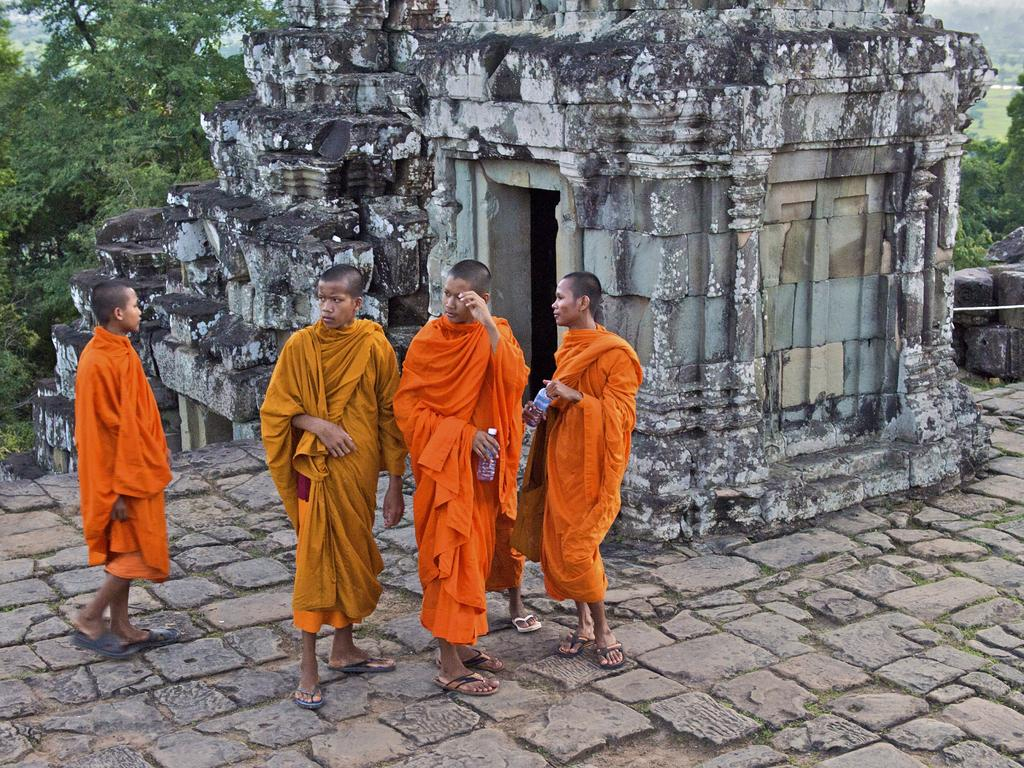What is happening in the image? There are people standing in the image. What can be seen in the background of the image? There is an architecture with stone walls and trees in the background. Are there any specific features on the right side of the image? Yes, there are stones on the right side of the image. What type of hat is the teacher wearing in the image? There is no teacher or hat present in the image. 